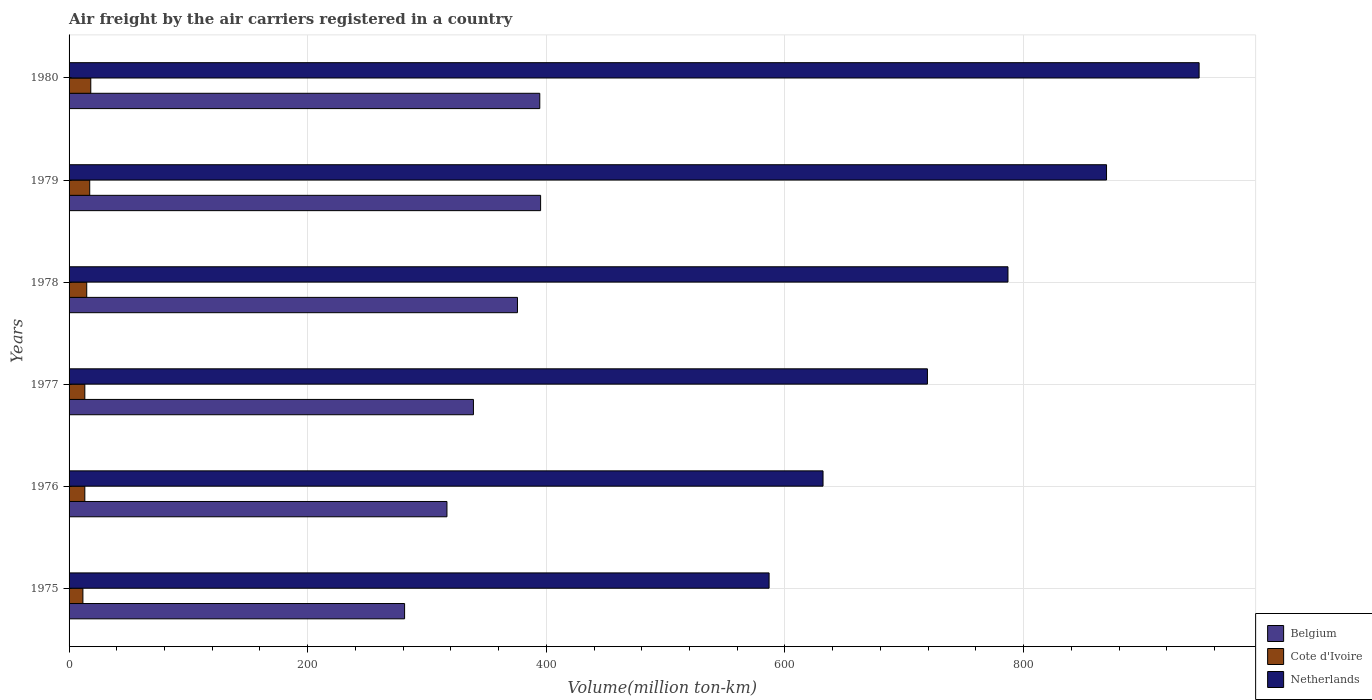What is the label of the 3rd group of bars from the top?
Your response must be concise. 1978. What is the volume of the air carriers in Cote d'Ivoire in 1975?
Provide a short and direct response. 11.6. Across all years, what is the maximum volume of the air carriers in Netherlands?
Keep it short and to the point. 947.1. Across all years, what is the minimum volume of the air carriers in Belgium?
Your response must be concise. 281.2. In which year was the volume of the air carriers in Belgium maximum?
Make the answer very short. 1979. In which year was the volume of the air carriers in Belgium minimum?
Offer a very short reply. 1975. What is the total volume of the air carriers in Cote d'Ivoire in the graph?
Offer a terse response. 88.3. What is the difference between the volume of the air carriers in Cote d'Ivoire in 1975 and that in 1977?
Make the answer very short. -1.6. What is the difference between the volume of the air carriers in Cote d'Ivoire in 1980 and the volume of the air carriers in Belgium in 1977?
Provide a short and direct response. -320.7. What is the average volume of the air carriers in Belgium per year?
Offer a very short reply. 350.38. In the year 1976, what is the difference between the volume of the air carriers in Netherlands and volume of the air carriers in Cote d'Ivoire?
Offer a very short reply. 618.7. What is the ratio of the volume of the air carriers in Netherlands in 1975 to that in 1978?
Give a very brief answer. 0.75. What is the difference between the highest and the second highest volume of the air carriers in Netherlands?
Ensure brevity in your answer.  77.6. What is the difference between the highest and the lowest volume of the air carriers in Belgium?
Your answer should be compact. 114. In how many years, is the volume of the air carriers in Netherlands greater than the average volume of the air carriers in Netherlands taken over all years?
Offer a terse response. 3. How many bars are there?
Keep it short and to the point. 18. Are all the bars in the graph horizontal?
Make the answer very short. Yes. How many years are there in the graph?
Your answer should be very brief. 6. What is the difference between two consecutive major ticks on the X-axis?
Your answer should be very brief. 200. Are the values on the major ticks of X-axis written in scientific E-notation?
Your answer should be compact. No. Does the graph contain any zero values?
Provide a short and direct response. No. Where does the legend appear in the graph?
Your response must be concise. Bottom right. What is the title of the graph?
Offer a very short reply. Air freight by the air carriers registered in a country. What is the label or title of the X-axis?
Provide a succinct answer. Volume(million ton-km). What is the Volume(million ton-km) of Belgium in 1975?
Provide a succinct answer. 281.2. What is the Volume(million ton-km) of Cote d'Ivoire in 1975?
Your answer should be very brief. 11.6. What is the Volume(million ton-km) in Netherlands in 1975?
Keep it short and to the point. 586.7. What is the Volume(million ton-km) in Belgium in 1976?
Provide a short and direct response. 316.7. What is the Volume(million ton-km) of Cote d'Ivoire in 1976?
Offer a terse response. 13.2. What is the Volume(million ton-km) in Netherlands in 1976?
Keep it short and to the point. 631.9. What is the Volume(million ton-km) in Belgium in 1977?
Make the answer very short. 338.9. What is the Volume(million ton-km) in Cote d'Ivoire in 1977?
Make the answer very short. 13.2. What is the Volume(million ton-km) in Netherlands in 1977?
Make the answer very short. 719.4. What is the Volume(million ton-km) in Belgium in 1978?
Your response must be concise. 375.8. What is the Volume(million ton-km) in Cote d'Ivoire in 1978?
Your answer should be compact. 14.8. What is the Volume(million ton-km) in Netherlands in 1978?
Your response must be concise. 786.9. What is the Volume(million ton-km) in Belgium in 1979?
Your answer should be very brief. 395.2. What is the Volume(million ton-km) of Cote d'Ivoire in 1979?
Your answer should be very brief. 17.3. What is the Volume(million ton-km) of Netherlands in 1979?
Your response must be concise. 869.5. What is the Volume(million ton-km) in Belgium in 1980?
Offer a very short reply. 394.5. What is the Volume(million ton-km) of Cote d'Ivoire in 1980?
Your answer should be very brief. 18.2. What is the Volume(million ton-km) in Netherlands in 1980?
Your answer should be compact. 947.1. Across all years, what is the maximum Volume(million ton-km) in Belgium?
Provide a short and direct response. 395.2. Across all years, what is the maximum Volume(million ton-km) in Cote d'Ivoire?
Give a very brief answer. 18.2. Across all years, what is the maximum Volume(million ton-km) in Netherlands?
Provide a succinct answer. 947.1. Across all years, what is the minimum Volume(million ton-km) of Belgium?
Your answer should be very brief. 281.2. Across all years, what is the minimum Volume(million ton-km) in Cote d'Ivoire?
Provide a short and direct response. 11.6. Across all years, what is the minimum Volume(million ton-km) in Netherlands?
Provide a short and direct response. 586.7. What is the total Volume(million ton-km) of Belgium in the graph?
Make the answer very short. 2102.3. What is the total Volume(million ton-km) in Cote d'Ivoire in the graph?
Your answer should be compact. 88.3. What is the total Volume(million ton-km) in Netherlands in the graph?
Provide a succinct answer. 4541.5. What is the difference between the Volume(million ton-km) in Belgium in 1975 and that in 1976?
Ensure brevity in your answer.  -35.5. What is the difference between the Volume(million ton-km) of Netherlands in 1975 and that in 1976?
Your response must be concise. -45.2. What is the difference between the Volume(million ton-km) of Belgium in 1975 and that in 1977?
Your answer should be compact. -57.7. What is the difference between the Volume(million ton-km) in Cote d'Ivoire in 1975 and that in 1977?
Your answer should be very brief. -1.6. What is the difference between the Volume(million ton-km) in Netherlands in 1975 and that in 1977?
Offer a terse response. -132.7. What is the difference between the Volume(million ton-km) of Belgium in 1975 and that in 1978?
Provide a short and direct response. -94.6. What is the difference between the Volume(million ton-km) in Cote d'Ivoire in 1975 and that in 1978?
Provide a succinct answer. -3.2. What is the difference between the Volume(million ton-km) in Netherlands in 1975 and that in 1978?
Your response must be concise. -200.2. What is the difference between the Volume(million ton-km) of Belgium in 1975 and that in 1979?
Provide a succinct answer. -114. What is the difference between the Volume(million ton-km) of Netherlands in 1975 and that in 1979?
Your answer should be very brief. -282.8. What is the difference between the Volume(million ton-km) of Belgium in 1975 and that in 1980?
Ensure brevity in your answer.  -113.3. What is the difference between the Volume(million ton-km) in Cote d'Ivoire in 1975 and that in 1980?
Provide a succinct answer. -6.6. What is the difference between the Volume(million ton-km) in Netherlands in 1975 and that in 1980?
Your response must be concise. -360.4. What is the difference between the Volume(million ton-km) in Belgium in 1976 and that in 1977?
Provide a succinct answer. -22.2. What is the difference between the Volume(million ton-km) of Cote d'Ivoire in 1976 and that in 1977?
Provide a short and direct response. 0. What is the difference between the Volume(million ton-km) of Netherlands in 1976 and that in 1977?
Provide a short and direct response. -87.5. What is the difference between the Volume(million ton-km) of Belgium in 1976 and that in 1978?
Make the answer very short. -59.1. What is the difference between the Volume(million ton-km) of Cote d'Ivoire in 1976 and that in 1978?
Your answer should be compact. -1.6. What is the difference between the Volume(million ton-km) in Netherlands in 1976 and that in 1978?
Provide a short and direct response. -155. What is the difference between the Volume(million ton-km) of Belgium in 1976 and that in 1979?
Ensure brevity in your answer.  -78.5. What is the difference between the Volume(million ton-km) of Netherlands in 1976 and that in 1979?
Keep it short and to the point. -237.6. What is the difference between the Volume(million ton-km) in Belgium in 1976 and that in 1980?
Your answer should be very brief. -77.8. What is the difference between the Volume(million ton-km) in Cote d'Ivoire in 1976 and that in 1980?
Give a very brief answer. -5. What is the difference between the Volume(million ton-km) of Netherlands in 1976 and that in 1980?
Offer a very short reply. -315.2. What is the difference between the Volume(million ton-km) of Belgium in 1977 and that in 1978?
Make the answer very short. -36.9. What is the difference between the Volume(million ton-km) of Cote d'Ivoire in 1977 and that in 1978?
Offer a very short reply. -1.6. What is the difference between the Volume(million ton-km) in Netherlands in 1977 and that in 1978?
Ensure brevity in your answer.  -67.5. What is the difference between the Volume(million ton-km) of Belgium in 1977 and that in 1979?
Provide a short and direct response. -56.3. What is the difference between the Volume(million ton-km) in Cote d'Ivoire in 1977 and that in 1979?
Offer a very short reply. -4.1. What is the difference between the Volume(million ton-km) in Netherlands in 1977 and that in 1979?
Provide a succinct answer. -150.1. What is the difference between the Volume(million ton-km) in Belgium in 1977 and that in 1980?
Ensure brevity in your answer.  -55.6. What is the difference between the Volume(million ton-km) in Netherlands in 1977 and that in 1980?
Offer a very short reply. -227.7. What is the difference between the Volume(million ton-km) in Belgium in 1978 and that in 1979?
Offer a very short reply. -19.4. What is the difference between the Volume(million ton-km) in Cote d'Ivoire in 1978 and that in 1979?
Your answer should be compact. -2.5. What is the difference between the Volume(million ton-km) of Netherlands in 1978 and that in 1979?
Give a very brief answer. -82.6. What is the difference between the Volume(million ton-km) of Belgium in 1978 and that in 1980?
Ensure brevity in your answer.  -18.7. What is the difference between the Volume(million ton-km) of Cote d'Ivoire in 1978 and that in 1980?
Your answer should be very brief. -3.4. What is the difference between the Volume(million ton-km) in Netherlands in 1978 and that in 1980?
Give a very brief answer. -160.2. What is the difference between the Volume(million ton-km) in Belgium in 1979 and that in 1980?
Provide a succinct answer. 0.7. What is the difference between the Volume(million ton-km) of Cote d'Ivoire in 1979 and that in 1980?
Offer a very short reply. -0.9. What is the difference between the Volume(million ton-km) of Netherlands in 1979 and that in 1980?
Your response must be concise. -77.6. What is the difference between the Volume(million ton-km) of Belgium in 1975 and the Volume(million ton-km) of Cote d'Ivoire in 1976?
Your answer should be compact. 268. What is the difference between the Volume(million ton-km) of Belgium in 1975 and the Volume(million ton-km) of Netherlands in 1976?
Your answer should be compact. -350.7. What is the difference between the Volume(million ton-km) in Cote d'Ivoire in 1975 and the Volume(million ton-km) in Netherlands in 1976?
Offer a very short reply. -620.3. What is the difference between the Volume(million ton-km) in Belgium in 1975 and the Volume(million ton-km) in Cote d'Ivoire in 1977?
Your answer should be very brief. 268. What is the difference between the Volume(million ton-km) in Belgium in 1975 and the Volume(million ton-km) in Netherlands in 1977?
Your answer should be very brief. -438.2. What is the difference between the Volume(million ton-km) of Cote d'Ivoire in 1975 and the Volume(million ton-km) of Netherlands in 1977?
Give a very brief answer. -707.8. What is the difference between the Volume(million ton-km) in Belgium in 1975 and the Volume(million ton-km) in Cote d'Ivoire in 1978?
Provide a succinct answer. 266.4. What is the difference between the Volume(million ton-km) of Belgium in 1975 and the Volume(million ton-km) of Netherlands in 1978?
Provide a succinct answer. -505.7. What is the difference between the Volume(million ton-km) of Cote d'Ivoire in 1975 and the Volume(million ton-km) of Netherlands in 1978?
Keep it short and to the point. -775.3. What is the difference between the Volume(million ton-km) in Belgium in 1975 and the Volume(million ton-km) in Cote d'Ivoire in 1979?
Provide a short and direct response. 263.9. What is the difference between the Volume(million ton-km) in Belgium in 1975 and the Volume(million ton-km) in Netherlands in 1979?
Your answer should be very brief. -588.3. What is the difference between the Volume(million ton-km) of Cote d'Ivoire in 1975 and the Volume(million ton-km) of Netherlands in 1979?
Give a very brief answer. -857.9. What is the difference between the Volume(million ton-km) of Belgium in 1975 and the Volume(million ton-km) of Cote d'Ivoire in 1980?
Give a very brief answer. 263. What is the difference between the Volume(million ton-km) in Belgium in 1975 and the Volume(million ton-km) in Netherlands in 1980?
Offer a very short reply. -665.9. What is the difference between the Volume(million ton-km) of Cote d'Ivoire in 1975 and the Volume(million ton-km) of Netherlands in 1980?
Your answer should be compact. -935.5. What is the difference between the Volume(million ton-km) of Belgium in 1976 and the Volume(million ton-km) of Cote d'Ivoire in 1977?
Your answer should be compact. 303.5. What is the difference between the Volume(million ton-km) of Belgium in 1976 and the Volume(million ton-km) of Netherlands in 1977?
Your answer should be very brief. -402.7. What is the difference between the Volume(million ton-km) of Cote d'Ivoire in 1976 and the Volume(million ton-km) of Netherlands in 1977?
Offer a very short reply. -706.2. What is the difference between the Volume(million ton-km) in Belgium in 1976 and the Volume(million ton-km) in Cote d'Ivoire in 1978?
Provide a succinct answer. 301.9. What is the difference between the Volume(million ton-km) of Belgium in 1976 and the Volume(million ton-km) of Netherlands in 1978?
Keep it short and to the point. -470.2. What is the difference between the Volume(million ton-km) of Cote d'Ivoire in 1976 and the Volume(million ton-km) of Netherlands in 1978?
Offer a terse response. -773.7. What is the difference between the Volume(million ton-km) in Belgium in 1976 and the Volume(million ton-km) in Cote d'Ivoire in 1979?
Ensure brevity in your answer.  299.4. What is the difference between the Volume(million ton-km) in Belgium in 1976 and the Volume(million ton-km) in Netherlands in 1979?
Provide a short and direct response. -552.8. What is the difference between the Volume(million ton-km) of Cote d'Ivoire in 1976 and the Volume(million ton-km) of Netherlands in 1979?
Your response must be concise. -856.3. What is the difference between the Volume(million ton-km) in Belgium in 1976 and the Volume(million ton-km) in Cote d'Ivoire in 1980?
Your answer should be very brief. 298.5. What is the difference between the Volume(million ton-km) of Belgium in 1976 and the Volume(million ton-km) of Netherlands in 1980?
Provide a succinct answer. -630.4. What is the difference between the Volume(million ton-km) in Cote d'Ivoire in 1976 and the Volume(million ton-km) in Netherlands in 1980?
Give a very brief answer. -933.9. What is the difference between the Volume(million ton-km) in Belgium in 1977 and the Volume(million ton-km) in Cote d'Ivoire in 1978?
Provide a short and direct response. 324.1. What is the difference between the Volume(million ton-km) of Belgium in 1977 and the Volume(million ton-km) of Netherlands in 1978?
Your response must be concise. -448. What is the difference between the Volume(million ton-km) of Cote d'Ivoire in 1977 and the Volume(million ton-km) of Netherlands in 1978?
Provide a succinct answer. -773.7. What is the difference between the Volume(million ton-km) in Belgium in 1977 and the Volume(million ton-km) in Cote d'Ivoire in 1979?
Your response must be concise. 321.6. What is the difference between the Volume(million ton-km) in Belgium in 1977 and the Volume(million ton-km) in Netherlands in 1979?
Give a very brief answer. -530.6. What is the difference between the Volume(million ton-km) of Cote d'Ivoire in 1977 and the Volume(million ton-km) of Netherlands in 1979?
Provide a succinct answer. -856.3. What is the difference between the Volume(million ton-km) in Belgium in 1977 and the Volume(million ton-km) in Cote d'Ivoire in 1980?
Provide a succinct answer. 320.7. What is the difference between the Volume(million ton-km) of Belgium in 1977 and the Volume(million ton-km) of Netherlands in 1980?
Give a very brief answer. -608.2. What is the difference between the Volume(million ton-km) of Cote d'Ivoire in 1977 and the Volume(million ton-km) of Netherlands in 1980?
Your response must be concise. -933.9. What is the difference between the Volume(million ton-km) of Belgium in 1978 and the Volume(million ton-km) of Cote d'Ivoire in 1979?
Give a very brief answer. 358.5. What is the difference between the Volume(million ton-km) of Belgium in 1978 and the Volume(million ton-km) of Netherlands in 1979?
Offer a very short reply. -493.7. What is the difference between the Volume(million ton-km) in Cote d'Ivoire in 1978 and the Volume(million ton-km) in Netherlands in 1979?
Offer a terse response. -854.7. What is the difference between the Volume(million ton-km) of Belgium in 1978 and the Volume(million ton-km) of Cote d'Ivoire in 1980?
Offer a terse response. 357.6. What is the difference between the Volume(million ton-km) of Belgium in 1978 and the Volume(million ton-km) of Netherlands in 1980?
Your answer should be very brief. -571.3. What is the difference between the Volume(million ton-km) of Cote d'Ivoire in 1978 and the Volume(million ton-km) of Netherlands in 1980?
Your response must be concise. -932.3. What is the difference between the Volume(million ton-km) of Belgium in 1979 and the Volume(million ton-km) of Cote d'Ivoire in 1980?
Provide a short and direct response. 377. What is the difference between the Volume(million ton-km) in Belgium in 1979 and the Volume(million ton-km) in Netherlands in 1980?
Your answer should be very brief. -551.9. What is the difference between the Volume(million ton-km) of Cote d'Ivoire in 1979 and the Volume(million ton-km) of Netherlands in 1980?
Keep it short and to the point. -929.8. What is the average Volume(million ton-km) of Belgium per year?
Give a very brief answer. 350.38. What is the average Volume(million ton-km) in Cote d'Ivoire per year?
Your response must be concise. 14.72. What is the average Volume(million ton-km) in Netherlands per year?
Your response must be concise. 756.92. In the year 1975, what is the difference between the Volume(million ton-km) in Belgium and Volume(million ton-km) in Cote d'Ivoire?
Your response must be concise. 269.6. In the year 1975, what is the difference between the Volume(million ton-km) in Belgium and Volume(million ton-km) in Netherlands?
Your response must be concise. -305.5. In the year 1975, what is the difference between the Volume(million ton-km) in Cote d'Ivoire and Volume(million ton-km) in Netherlands?
Offer a very short reply. -575.1. In the year 1976, what is the difference between the Volume(million ton-km) in Belgium and Volume(million ton-km) in Cote d'Ivoire?
Give a very brief answer. 303.5. In the year 1976, what is the difference between the Volume(million ton-km) of Belgium and Volume(million ton-km) of Netherlands?
Offer a very short reply. -315.2. In the year 1976, what is the difference between the Volume(million ton-km) in Cote d'Ivoire and Volume(million ton-km) in Netherlands?
Your answer should be very brief. -618.7. In the year 1977, what is the difference between the Volume(million ton-km) of Belgium and Volume(million ton-km) of Cote d'Ivoire?
Offer a terse response. 325.7. In the year 1977, what is the difference between the Volume(million ton-km) of Belgium and Volume(million ton-km) of Netherlands?
Offer a very short reply. -380.5. In the year 1977, what is the difference between the Volume(million ton-km) of Cote d'Ivoire and Volume(million ton-km) of Netherlands?
Offer a very short reply. -706.2. In the year 1978, what is the difference between the Volume(million ton-km) in Belgium and Volume(million ton-km) in Cote d'Ivoire?
Offer a very short reply. 361. In the year 1978, what is the difference between the Volume(million ton-km) in Belgium and Volume(million ton-km) in Netherlands?
Keep it short and to the point. -411.1. In the year 1978, what is the difference between the Volume(million ton-km) of Cote d'Ivoire and Volume(million ton-km) of Netherlands?
Your answer should be compact. -772.1. In the year 1979, what is the difference between the Volume(million ton-km) in Belgium and Volume(million ton-km) in Cote d'Ivoire?
Your answer should be compact. 377.9. In the year 1979, what is the difference between the Volume(million ton-km) in Belgium and Volume(million ton-km) in Netherlands?
Your answer should be very brief. -474.3. In the year 1979, what is the difference between the Volume(million ton-km) in Cote d'Ivoire and Volume(million ton-km) in Netherlands?
Your response must be concise. -852.2. In the year 1980, what is the difference between the Volume(million ton-km) of Belgium and Volume(million ton-km) of Cote d'Ivoire?
Your answer should be very brief. 376.3. In the year 1980, what is the difference between the Volume(million ton-km) in Belgium and Volume(million ton-km) in Netherlands?
Keep it short and to the point. -552.6. In the year 1980, what is the difference between the Volume(million ton-km) in Cote d'Ivoire and Volume(million ton-km) in Netherlands?
Provide a short and direct response. -928.9. What is the ratio of the Volume(million ton-km) of Belgium in 1975 to that in 1976?
Your response must be concise. 0.89. What is the ratio of the Volume(million ton-km) in Cote d'Ivoire in 1975 to that in 1976?
Your response must be concise. 0.88. What is the ratio of the Volume(million ton-km) of Netherlands in 1975 to that in 1976?
Provide a short and direct response. 0.93. What is the ratio of the Volume(million ton-km) in Belgium in 1975 to that in 1977?
Your answer should be compact. 0.83. What is the ratio of the Volume(million ton-km) in Cote d'Ivoire in 1975 to that in 1977?
Give a very brief answer. 0.88. What is the ratio of the Volume(million ton-km) in Netherlands in 1975 to that in 1977?
Your response must be concise. 0.82. What is the ratio of the Volume(million ton-km) in Belgium in 1975 to that in 1978?
Your response must be concise. 0.75. What is the ratio of the Volume(million ton-km) in Cote d'Ivoire in 1975 to that in 1978?
Keep it short and to the point. 0.78. What is the ratio of the Volume(million ton-km) of Netherlands in 1975 to that in 1978?
Give a very brief answer. 0.75. What is the ratio of the Volume(million ton-km) in Belgium in 1975 to that in 1979?
Make the answer very short. 0.71. What is the ratio of the Volume(million ton-km) of Cote d'Ivoire in 1975 to that in 1979?
Your answer should be very brief. 0.67. What is the ratio of the Volume(million ton-km) in Netherlands in 1975 to that in 1979?
Provide a short and direct response. 0.67. What is the ratio of the Volume(million ton-km) of Belgium in 1975 to that in 1980?
Your answer should be very brief. 0.71. What is the ratio of the Volume(million ton-km) of Cote d'Ivoire in 1975 to that in 1980?
Provide a succinct answer. 0.64. What is the ratio of the Volume(million ton-km) in Netherlands in 1975 to that in 1980?
Your response must be concise. 0.62. What is the ratio of the Volume(million ton-km) of Belgium in 1976 to that in 1977?
Make the answer very short. 0.93. What is the ratio of the Volume(million ton-km) of Cote d'Ivoire in 1976 to that in 1977?
Provide a short and direct response. 1. What is the ratio of the Volume(million ton-km) in Netherlands in 1976 to that in 1977?
Ensure brevity in your answer.  0.88. What is the ratio of the Volume(million ton-km) of Belgium in 1976 to that in 1978?
Give a very brief answer. 0.84. What is the ratio of the Volume(million ton-km) of Cote d'Ivoire in 1976 to that in 1978?
Give a very brief answer. 0.89. What is the ratio of the Volume(million ton-km) of Netherlands in 1976 to that in 1978?
Keep it short and to the point. 0.8. What is the ratio of the Volume(million ton-km) of Belgium in 1976 to that in 1979?
Provide a succinct answer. 0.8. What is the ratio of the Volume(million ton-km) of Cote d'Ivoire in 1976 to that in 1979?
Make the answer very short. 0.76. What is the ratio of the Volume(million ton-km) in Netherlands in 1976 to that in 1979?
Provide a succinct answer. 0.73. What is the ratio of the Volume(million ton-km) in Belgium in 1976 to that in 1980?
Make the answer very short. 0.8. What is the ratio of the Volume(million ton-km) in Cote d'Ivoire in 1976 to that in 1980?
Keep it short and to the point. 0.73. What is the ratio of the Volume(million ton-km) of Netherlands in 1976 to that in 1980?
Provide a succinct answer. 0.67. What is the ratio of the Volume(million ton-km) of Belgium in 1977 to that in 1978?
Your response must be concise. 0.9. What is the ratio of the Volume(million ton-km) of Cote d'Ivoire in 1977 to that in 1978?
Offer a very short reply. 0.89. What is the ratio of the Volume(million ton-km) in Netherlands in 1977 to that in 1978?
Offer a terse response. 0.91. What is the ratio of the Volume(million ton-km) in Belgium in 1977 to that in 1979?
Your answer should be very brief. 0.86. What is the ratio of the Volume(million ton-km) in Cote d'Ivoire in 1977 to that in 1979?
Your answer should be compact. 0.76. What is the ratio of the Volume(million ton-km) in Netherlands in 1977 to that in 1979?
Give a very brief answer. 0.83. What is the ratio of the Volume(million ton-km) of Belgium in 1977 to that in 1980?
Offer a terse response. 0.86. What is the ratio of the Volume(million ton-km) of Cote d'Ivoire in 1977 to that in 1980?
Give a very brief answer. 0.73. What is the ratio of the Volume(million ton-km) in Netherlands in 1977 to that in 1980?
Your response must be concise. 0.76. What is the ratio of the Volume(million ton-km) in Belgium in 1978 to that in 1979?
Your answer should be very brief. 0.95. What is the ratio of the Volume(million ton-km) of Cote d'Ivoire in 1978 to that in 1979?
Your answer should be very brief. 0.86. What is the ratio of the Volume(million ton-km) in Netherlands in 1978 to that in 1979?
Give a very brief answer. 0.91. What is the ratio of the Volume(million ton-km) of Belgium in 1978 to that in 1980?
Your answer should be compact. 0.95. What is the ratio of the Volume(million ton-km) in Cote d'Ivoire in 1978 to that in 1980?
Your answer should be compact. 0.81. What is the ratio of the Volume(million ton-km) in Netherlands in 1978 to that in 1980?
Keep it short and to the point. 0.83. What is the ratio of the Volume(million ton-km) of Cote d'Ivoire in 1979 to that in 1980?
Provide a succinct answer. 0.95. What is the ratio of the Volume(million ton-km) in Netherlands in 1979 to that in 1980?
Your answer should be compact. 0.92. What is the difference between the highest and the second highest Volume(million ton-km) of Netherlands?
Provide a short and direct response. 77.6. What is the difference between the highest and the lowest Volume(million ton-km) of Belgium?
Give a very brief answer. 114. What is the difference between the highest and the lowest Volume(million ton-km) of Netherlands?
Offer a terse response. 360.4. 